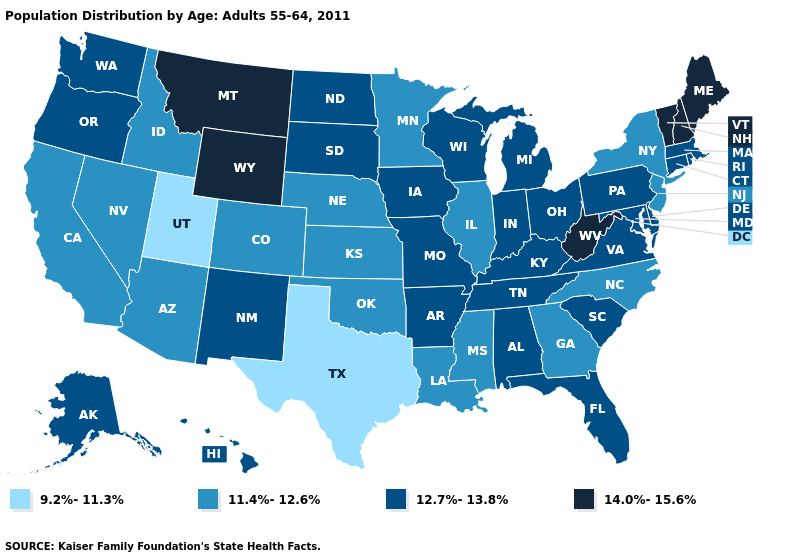Name the states that have a value in the range 12.7%-13.8%?
Be succinct. Alabama, Alaska, Arkansas, Connecticut, Delaware, Florida, Hawaii, Indiana, Iowa, Kentucky, Maryland, Massachusetts, Michigan, Missouri, New Mexico, North Dakota, Ohio, Oregon, Pennsylvania, Rhode Island, South Carolina, South Dakota, Tennessee, Virginia, Washington, Wisconsin. What is the value of Louisiana?
Answer briefly. 11.4%-12.6%. Does Alaska have a higher value than California?
Write a very short answer. Yes. What is the value of New York?
Concise answer only. 11.4%-12.6%. Name the states that have a value in the range 14.0%-15.6%?
Give a very brief answer. Maine, Montana, New Hampshire, Vermont, West Virginia, Wyoming. Name the states that have a value in the range 9.2%-11.3%?
Quick response, please. Texas, Utah. Name the states that have a value in the range 14.0%-15.6%?
Give a very brief answer. Maine, Montana, New Hampshire, Vermont, West Virginia, Wyoming. What is the value of Colorado?
Answer briefly. 11.4%-12.6%. Does Washington have a higher value than Minnesota?
Concise answer only. Yes. What is the value of Wyoming?
Short answer required. 14.0%-15.6%. What is the lowest value in the MidWest?
Concise answer only. 11.4%-12.6%. Name the states that have a value in the range 11.4%-12.6%?
Be succinct. Arizona, California, Colorado, Georgia, Idaho, Illinois, Kansas, Louisiana, Minnesota, Mississippi, Nebraska, Nevada, New Jersey, New York, North Carolina, Oklahoma. What is the value of Florida?
Answer briefly. 12.7%-13.8%. What is the lowest value in the USA?
Quick response, please. 9.2%-11.3%. Which states have the lowest value in the West?
Be succinct. Utah. 